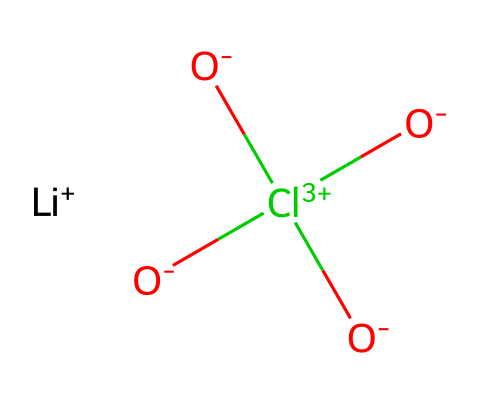What is the cation present in this chemical structure? The cation in the structure is indicated by [Li+], which represents lithium with a positive charge.
Answer: lithium How many oxygen atoms are present in this chemical structure? By analyzing the molecular structure, there are four oxygen atoms in total, two from the oxide ion (O-) and two from the carbonate ion (C(=O)(=O)=O).
Answer: four What is the charge of the anion in this chemical? The anion in the structure consists of a negatively charged oxide ion (O-) and a neutral carbonate group (Cl(=O)(=O)=O), which combines to have an overall charge of two from the oxide.
Answer: two Which type of electrolyte is represented by this chemical structure? This chemical represents an inorganic electrolyte, as it includes lithium (Li+) and an association of carbonate and oxide ions, commonly found in electrolytic solutions.
Answer: inorganic How many total atoms are there in the chemical structure? By counting the atoms, we find that there are one lithium atom, one chlorine atom, one carbon atom, four oxygen atoms, and one additional ion, resulting in a total of eight atoms.
Answer: eight Why is lithium used as a cation in electrolytes? Lithium is commonly used because of its small ionic radius, which allows for high conductivity and better performance in various applications, such as batteries and conductors.
Answer: small ionic radius What functional groups are present in this chemical structure? The functional groups present include a carbonate group (indicated by the structure C(=O)(=O)=O) and an oxide group, which are key to its behavior as an electrolyte.
Answer: carbonate and oxide 